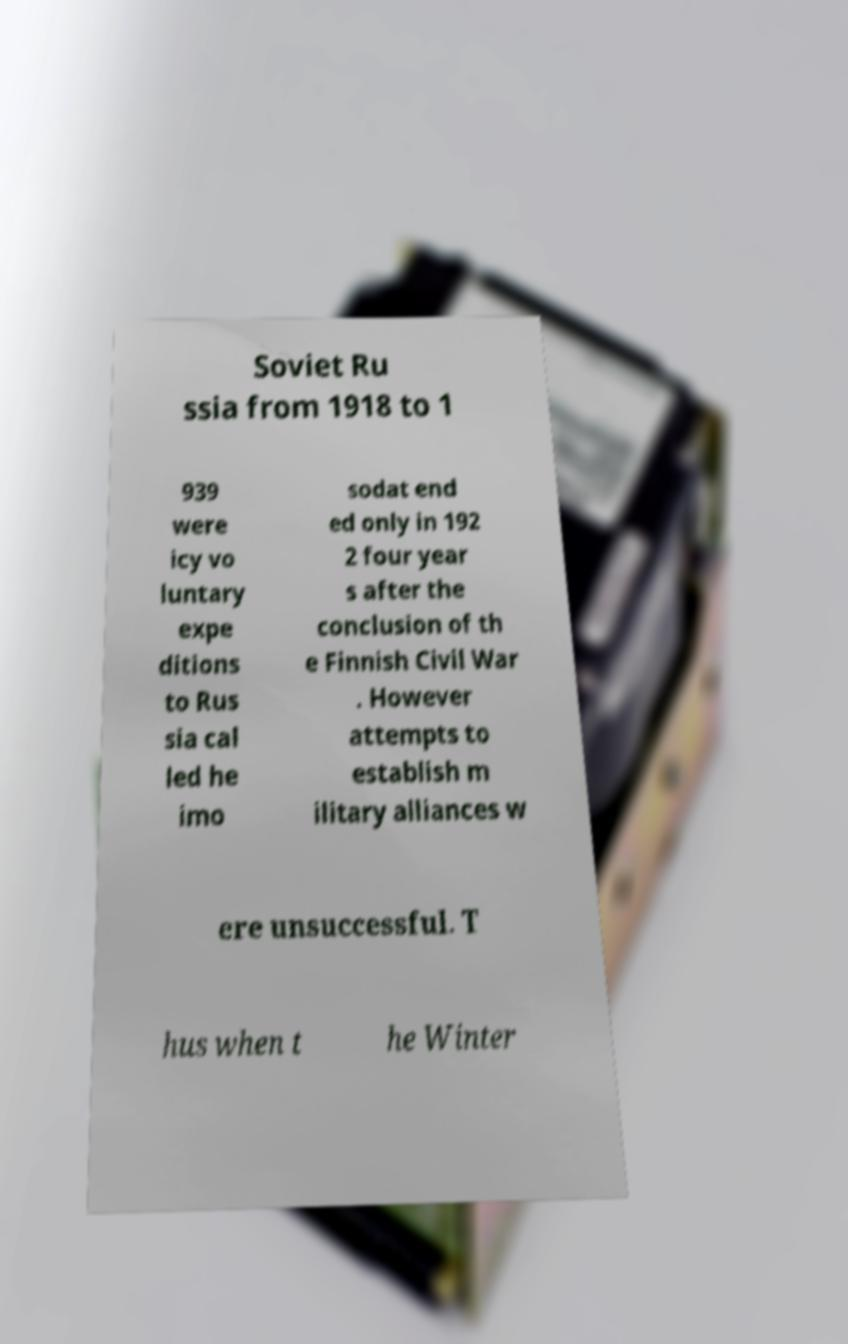Please read and relay the text visible in this image. What does it say? Soviet Ru ssia from 1918 to 1 939 were icy vo luntary expe ditions to Rus sia cal led he imo sodat end ed only in 192 2 four year s after the conclusion of th e Finnish Civil War . However attempts to establish m ilitary alliances w ere unsuccessful. T hus when t he Winter 